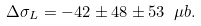Convert formula to latex. <formula><loc_0><loc_0><loc_500><loc_500>\Delta \sigma _ { L } = - 4 2 \pm 4 8 \pm 5 3 \ \mu b .</formula> 